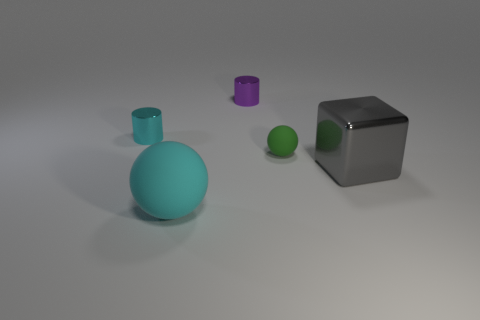What is the cyan thing that is in front of the cylinder left of the ball that is in front of the tiny rubber ball made of?
Make the answer very short. Rubber. Does the large thing that is to the right of the cyan sphere have the same color as the matte ball that is on the right side of the purple cylinder?
Offer a very short reply. No. There is a tiny thing behind the tiny cylinder to the left of the cyan matte object; what is its material?
Ensure brevity in your answer.  Metal. There is a thing that is the same size as the cyan sphere; what color is it?
Your response must be concise. Gray. There is a tiny green thing; is it the same shape as the tiny thing that is left of the big cyan thing?
Offer a very short reply. No. What shape is the shiny object that is the same color as the big matte object?
Provide a succinct answer. Cylinder. How many small shiny things are in front of the small metal thing that is on the right side of the matte thing to the left of the purple object?
Your answer should be compact. 1. There is a matte ball that is left of the matte thing that is behind the cyan rubber ball; what size is it?
Give a very brief answer. Large. There is another cylinder that is made of the same material as the purple cylinder; what is its size?
Keep it short and to the point. Small. There is a tiny object that is both on the right side of the cyan metallic object and in front of the small purple metal cylinder; what is its shape?
Provide a succinct answer. Sphere. 